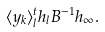Convert formula to latex. <formula><loc_0><loc_0><loc_500><loc_500>\langle y _ { k } \rangle _ { l } ^ { t } { h } _ { l } B ^ { - 1 } { h } _ { \infty } .</formula> 